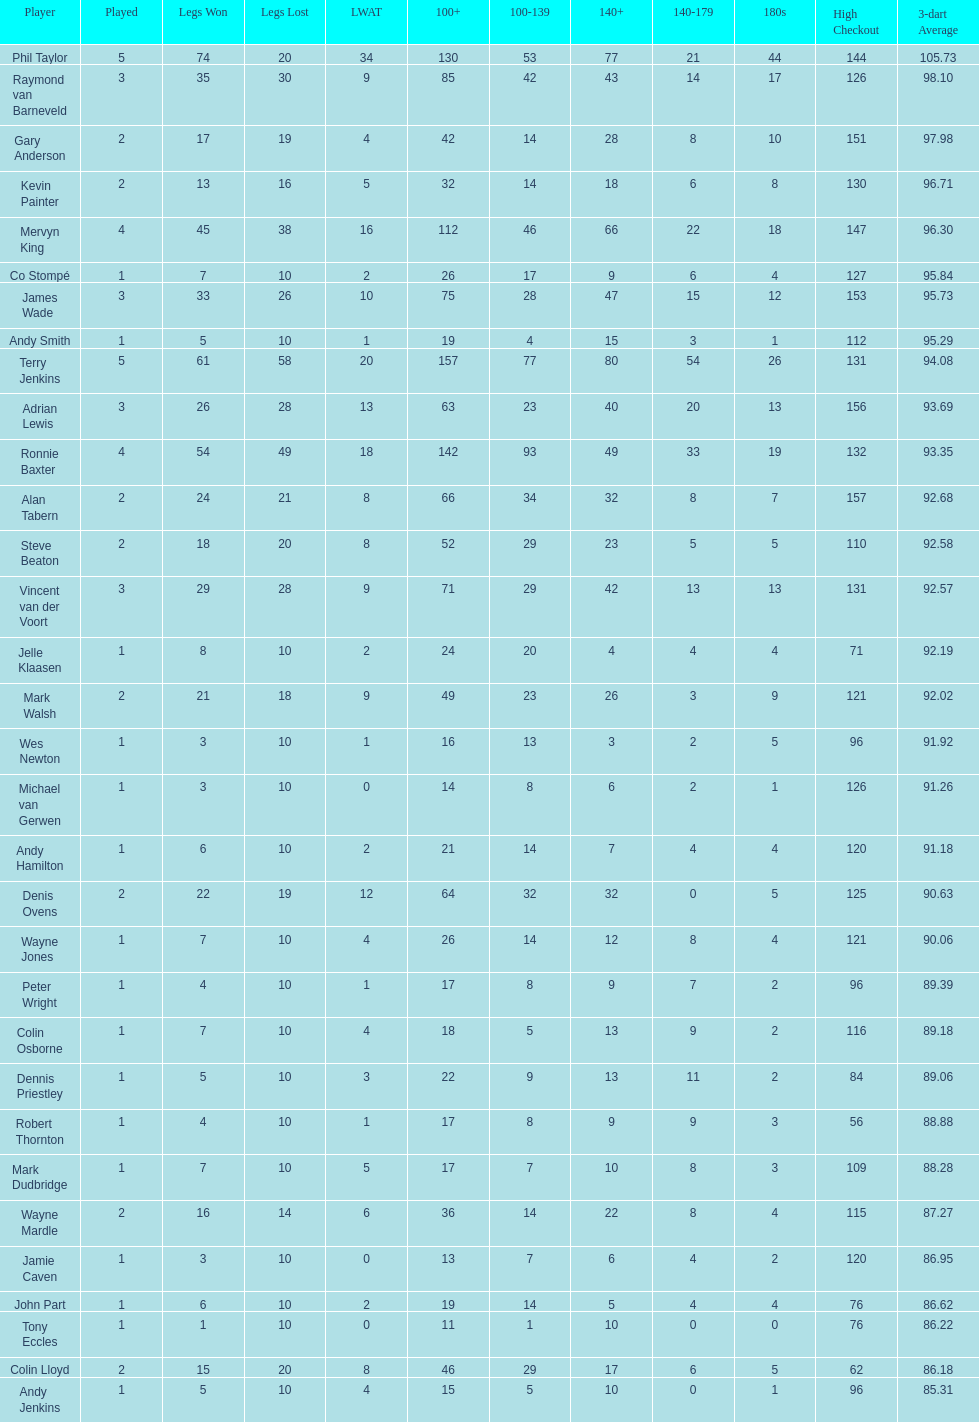What are the number of legs lost by james wade? 26. 